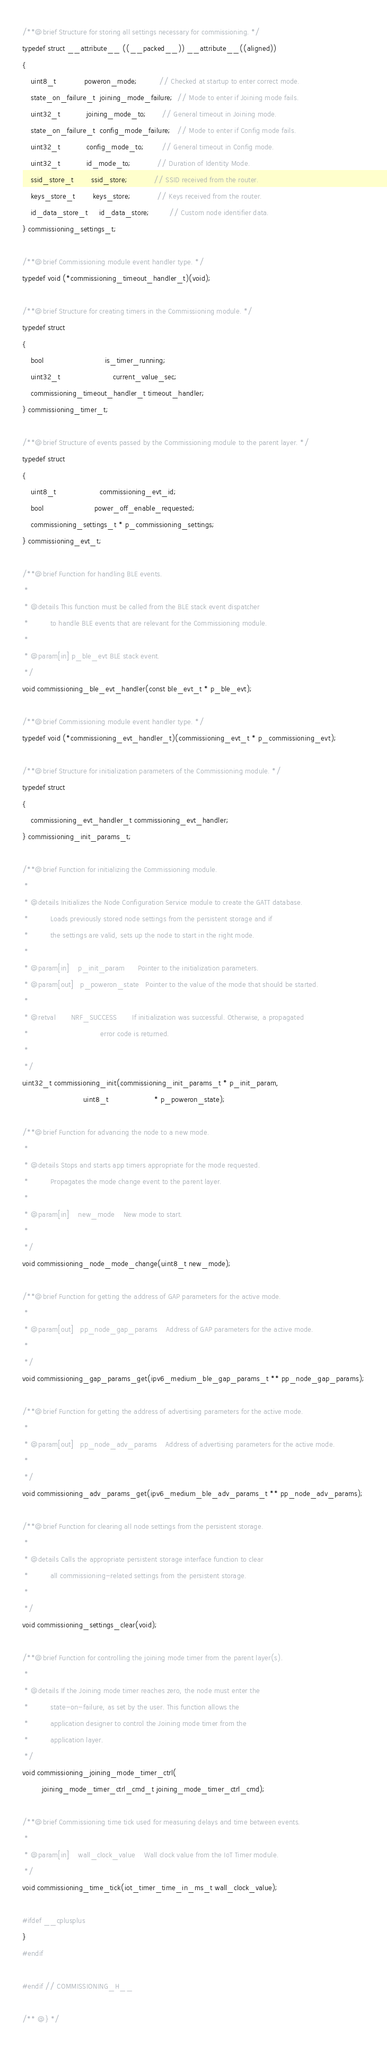Convert code to text. <code><loc_0><loc_0><loc_500><loc_500><_C_>/**@brief Structure for storing all settings necessary for commissioning. */
typedef struct __attribute__ ((__packed__)) __attribute__((aligned))
{
    uint8_t             poweron_mode;          // Checked at startup to enter correct mode.
    state_on_failure_t  joining_mode_failure;  // Mode to enter if Joining mode fails.
    uint32_t            joining_mode_to;       // General timeout in Joining mode.
    state_on_failure_t  config_mode_failure;   // Mode to enter if Config mode fails.
    uint32_t            config_mode_to;        // General timeout in Config mode.
    uint32_t            id_mode_to;            // Duration of Identity Mode.
    ssid_store_t        ssid_store;            // SSID received from the router.
    keys_store_t        keys_store;            // Keys received from the router.
    id_data_store_t     id_data_store;         // Custom node identifier data.
} commissioning_settings_t;

/**@brief Commissioning module event handler type. */
typedef void (*commissioning_timeout_handler_t)(void);

/**@brief Structure for creating timers in the Commissioning module. */
typedef struct
{
    bool                            is_timer_running;
    uint32_t                        current_value_sec;
    commissioning_timeout_handler_t timeout_handler;
} commissioning_timer_t;

/**@brief Structure of events passed by the Commissioning module to the parent layer. */
typedef struct
{
    uint8_t                    commissioning_evt_id;
    bool                       power_off_enable_requested;
    commissioning_settings_t * p_commissioning_settings;
} commissioning_evt_t;

/**@brief Function for handling BLE events.
 *
 * @details This function must be called from the BLE stack event dispatcher
 *          to handle BLE events that are relevant for the Commissioning module.
 *
 * @param[in] p_ble_evt BLE stack event.
 */
void commissioning_ble_evt_handler(const ble_evt_t * p_ble_evt);

/**@brief Commissioning module event handler type. */
typedef void (*commissioning_evt_handler_t)(commissioning_evt_t * p_commissioning_evt);

/**@brief Structure for initialization parameters of the Commissioning module. */
typedef struct
{
    commissioning_evt_handler_t commissioning_evt_handler;
} commissioning_init_params_t;

/**@brief Function for initializing the Commissioning module.
 *
 * @details Initializes the Node Configuration Service module to create the GATT database.
 *          Loads previously stored node settings from the persistent storage and if
 *          the settings are valid, sets up the node to start in the right mode.
 *
 * @param[in]    p_init_param      Pointer to the initialization parameters.
 * @param[out]   p_poweron_state   Pointer to the value of the mode that should be started.
 *
 * @retval       NRF_SUCCESS       If initialization was successful. Otherwise, a propagated
 *                                 error code is returned.
 *
 */
uint32_t commissioning_init(commissioning_init_params_t * p_init_param,
                            uint8_t                     * p_poweron_state);

/**@brief Function for advancing the node to a new mode.
 *
 * @details Stops and starts app timers appropriate for the mode requested.
 *          Propagates the mode change event to the parent layer.
 *
 * @param[in]    new_mode    New mode to start.
 *
 */
void commissioning_node_mode_change(uint8_t new_mode);

/**@brief Function for getting the address of GAP parameters for the active mode.
 *
 * @param[out]   pp_node_gap_params    Address of GAP parameters for the active mode.
 *
 */
void commissioning_gap_params_get(ipv6_medium_ble_gap_params_t ** pp_node_gap_params);

/**@brief Function for getting the address of advertising parameters for the active mode.
 *
 * @param[out]   pp_node_adv_params    Address of advertising parameters for the active mode.
 *
 */
void commissioning_adv_params_get(ipv6_medium_ble_adv_params_t ** pp_node_adv_params);

/**@brief Function for clearing all node settings from the persistent storage.
 *
 * @details Calls the appropriate persistent storage interface function to clear
 *          all commissioning-related settings from the persistent storage.
 *
 */
void commissioning_settings_clear(void);

/**@brief Function for controlling the joining mode timer from the parent layer(s).
 *
 * @details If the Joining mode timer reaches zero, the node must enter the
 *          state-on-failure, as set by the user. This function allows the
 *          application designer to control the Joining mode timer from the
 *          application layer.
 */
void commissioning_joining_mode_timer_ctrl(
         joining_mode_timer_ctrl_cmd_t joining_mode_timer_ctrl_cmd);

/**@brief Commissioning time tick used for measuring delays and time between events.
 *
 * @param[in]    wall_clock_value    Wall clock value from the IoT Timer module.
 */
void commissioning_time_tick(iot_timer_time_in_ms_t wall_clock_value);

#ifdef __cplusplus
}
#endif

#endif // COMMISSIONING_H__

/** @} */
</code> 